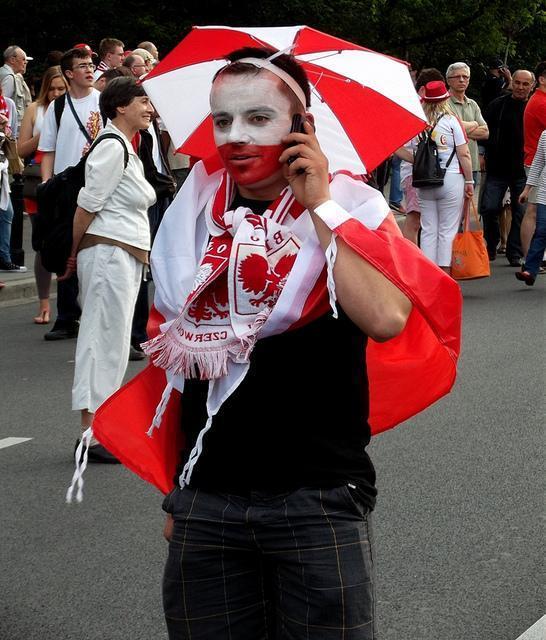How many people are there?
Give a very brief answer. 9. 